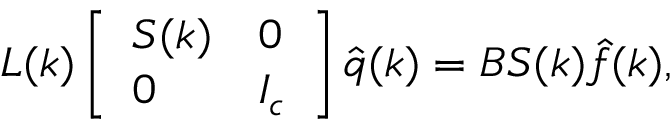Convert formula to latex. <formula><loc_0><loc_0><loc_500><loc_500>L ( k ) \left [ \begin{array} { l l } { S ( k ) } & { 0 } \\ { 0 } & { I _ { c } } \end{array} \right ] \hat { q } ( k ) = B S ( k ) \hat { f } ( k ) ,</formula> 